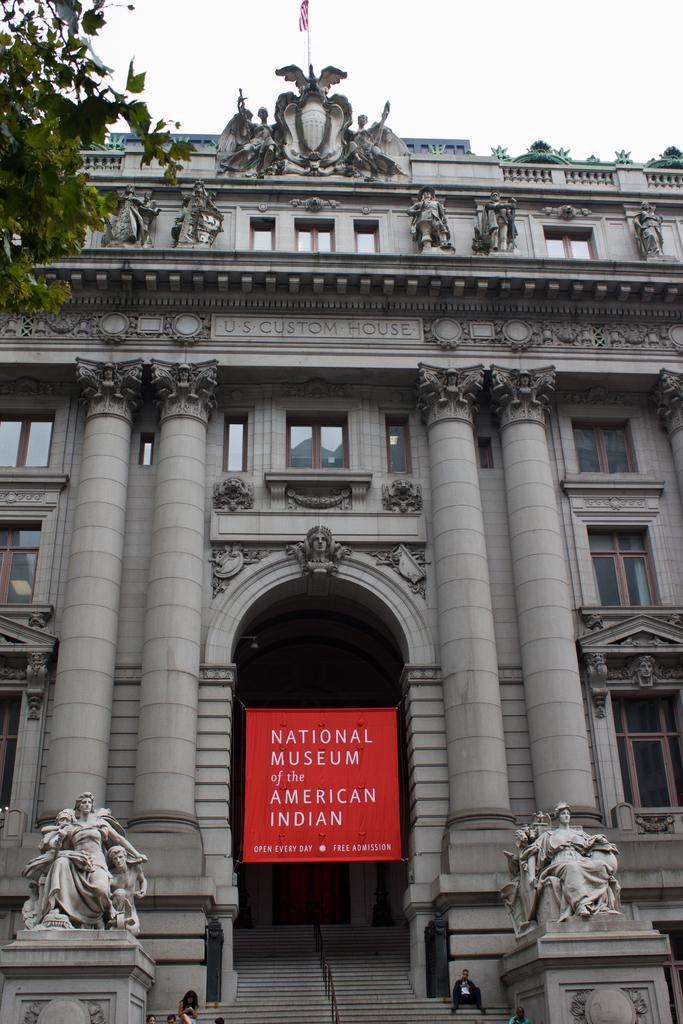Can you describe this image briefly? In the image there are statues on the pillars. At the bottom of the image there are steps and also there is railing. There are few people sitting on the steps. Behind them there is a building with walls, pillars,sculptures and many other things. And also there is a poster with text on it. In the top left corner of the image there are leaves. 